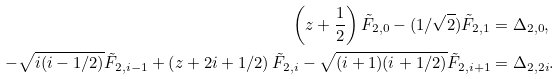Convert formula to latex. <formula><loc_0><loc_0><loc_500><loc_500>\left ( z + \frac { 1 } { 2 } \right ) \tilde { F } _ { 2 , 0 } - ( 1 / \sqrt { 2 } ) \tilde { F } _ { 2 , 1 } & = \Delta _ { 2 , 0 } , \\ - \sqrt { i ( i - 1 / 2 ) } \tilde { F } _ { 2 , i - 1 } + \left ( z + 2 i + 1 / 2 \right ) \tilde { F } _ { 2 , i } - \sqrt { ( i + 1 ) ( i + 1 / 2 ) } \tilde { F } _ { 2 , i + 1 } & = \Delta _ { 2 , 2 i } .</formula> 